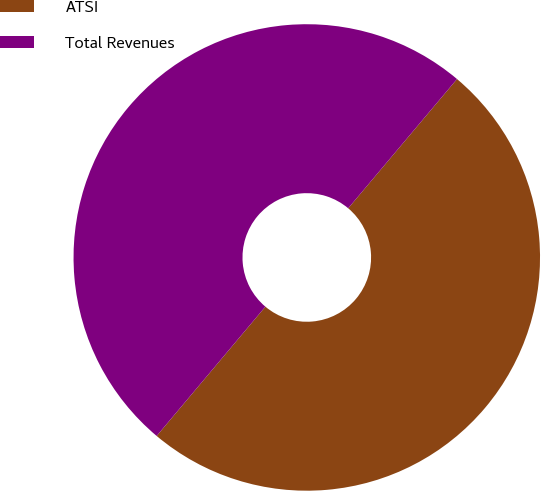<chart> <loc_0><loc_0><loc_500><loc_500><pie_chart><fcel>ATSI<fcel>Total Revenues<nl><fcel>49.99%<fcel>50.01%<nl></chart> 